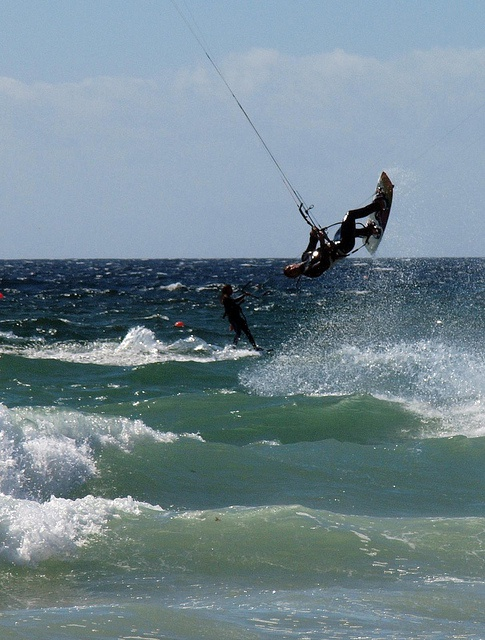Describe the objects in this image and their specific colors. I can see people in lightblue, black, gray, darkgray, and white tones, people in lightblue, black, gray, and darkblue tones, surfboard in lightblue, black, gray, darkgray, and purple tones, and surfboard in lightblue, lightgray, darkgray, blue, and gray tones in this image. 